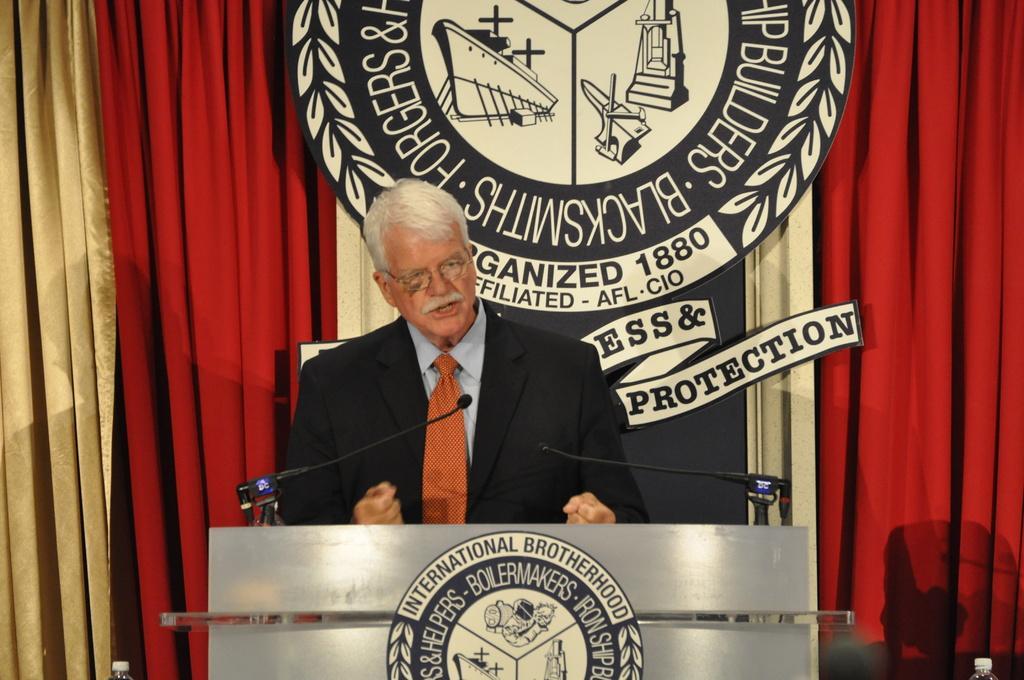Please provide a concise description of this image. Here in this picture we can see a person standing over a place and speaking something in the microphone that is present in front of him on the speech desk over there and we can see he is wearing a black colored coat on him and behind him we can see a curtain present and we can see a symbol in the middle of it over there. 